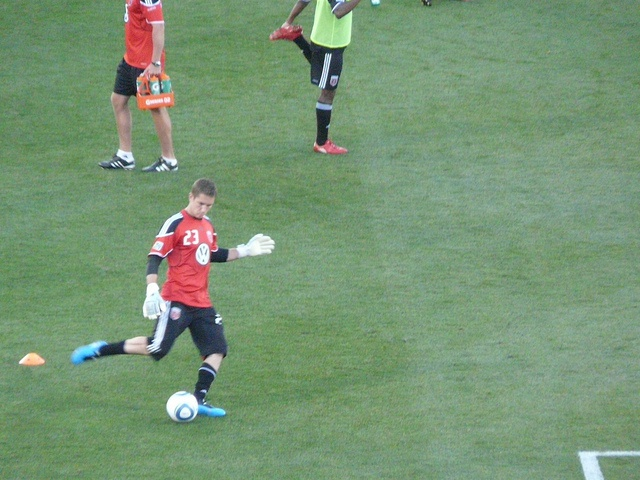Describe the objects in this image and their specific colors. I can see people in green, white, salmon, gray, and navy tones, people in green, salmon, darkgray, lightpink, and gray tones, people in green, lightgreen, black, and gray tones, and sports ball in green, white, lightblue, gray, and darkgray tones in this image. 